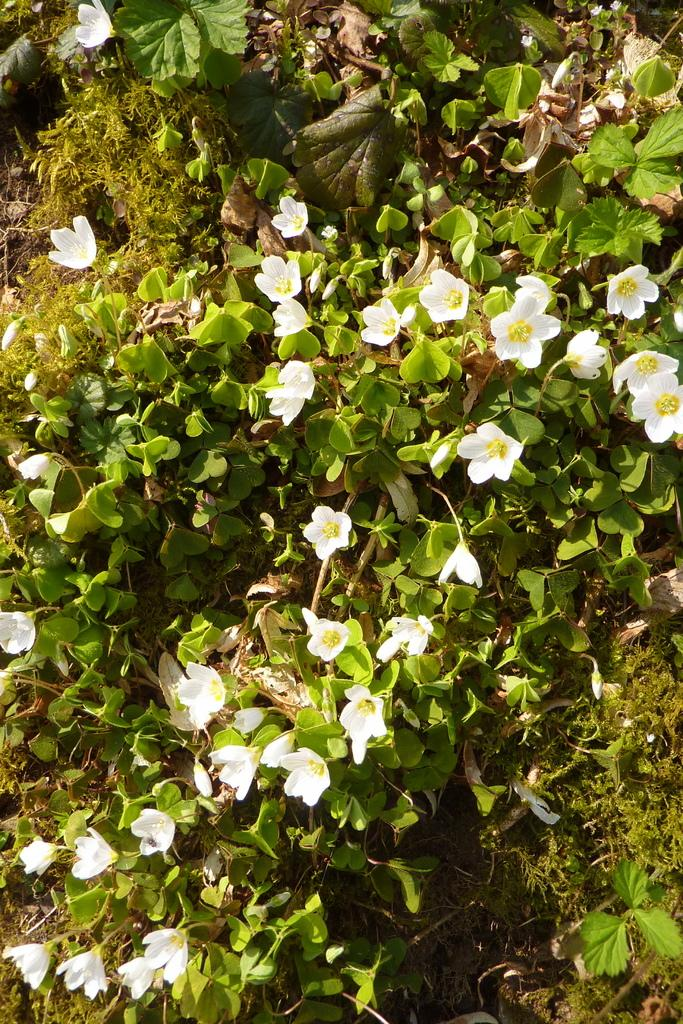What type of flowers can be seen in the image? There are white flowers in the image. What is the color of the plant on which the flowers are growing? The plant is green. What type of coal can be seen in the image? There is no coal present in the image; it features white flowers on a green plant. What color is the chalk used to draw on the orange in the image? There is no chalk or orange present in the image. 